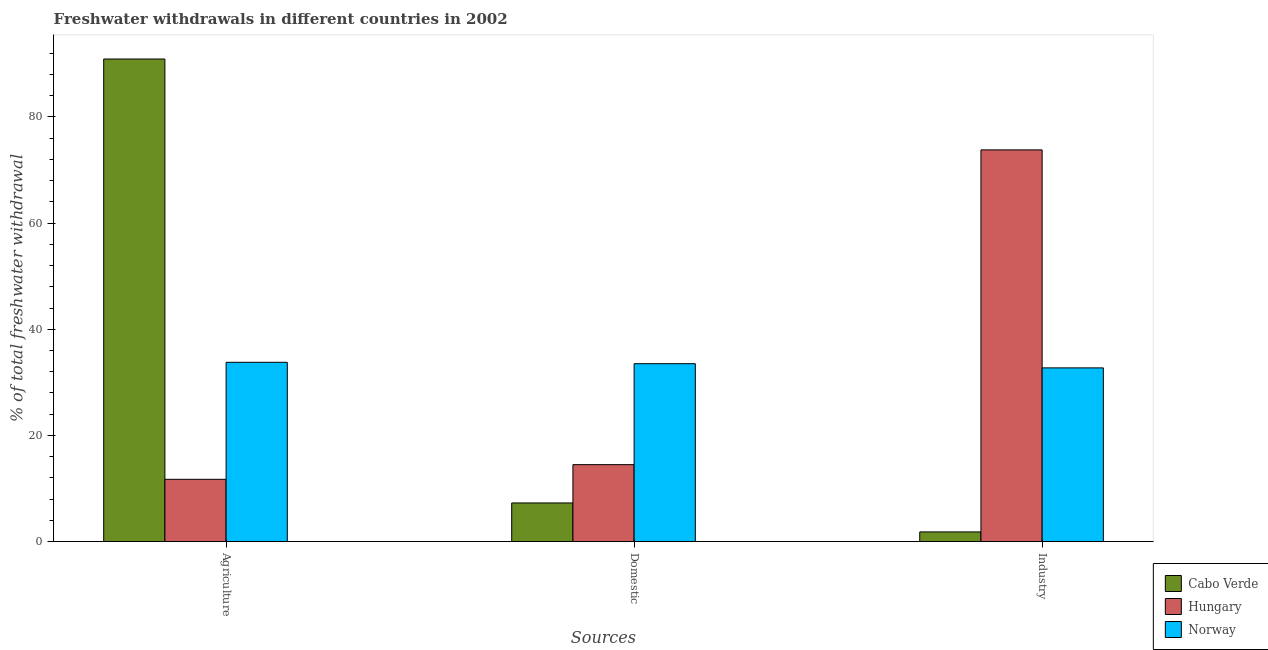How many different coloured bars are there?
Your answer should be compact. 3. Are the number of bars per tick equal to the number of legend labels?
Offer a terse response. Yes. Are the number of bars on each tick of the X-axis equal?
Your answer should be compact. Yes. How many bars are there on the 2nd tick from the right?
Offer a terse response. 3. What is the label of the 1st group of bars from the left?
Your response must be concise. Agriculture. What is the percentage of freshwater withdrawal for domestic purposes in Cabo Verde?
Give a very brief answer. 7.27. Across all countries, what is the maximum percentage of freshwater withdrawal for industry?
Provide a short and direct response. 73.79. Across all countries, what is the minimum percentage of freshwater withdrawal for domestic purposes?
Make the answer very short. 7.27. In which country was the percentage of freshwater withdrawal for domestic purposes maximum?
Offer a terse response. Norway. In which country was the percentage of freshwater withdrawal for domestic purposes minimum?
Provide a short and direct response. Cabo Verde. What is the total percentage of freshwater withdrawal for agriculture in the graph?
Your response must be concise. 136.41. What is the difference between the percentage of freshwater withdrawal for domestic purposes in Cabo Verde and that in Norway?
Your answer should be very brief. -26.24. What is the difference between the percentage of freshwater withdrawal for agriculture in Hungary and the percentage of freshwater withdrawal for domestic purposes in Norway?
Ensure brevity in your answer.  -21.78. What is the average percentage of freshwater withdrawal for industry per country?
Your answer should be very brief. 36.11. What is the difference between the percentage of freshwater withdrawal for domestic purposes and percentage of freshwater withdrawal for industry in Cabo Verde?
Offer a very short reply. 5.46. What is the ratio of the percentage of freshwater withdrawal for agriculture in Hungary to that in Norway?
Ensure brevity in your answer.  0.35. What is the difference between the highest and the second highest percentage of freshwater withdrawal for domestic purposes?
Ensure brevity in your answer.  19.02. What is the difference between the highest and the lowest percentage of freshwater withdrawal for industry?
Provide a short and direct response. 71.97. Is the sum of the percentage of freshwater withdrawal for domestic purposes in Norway and Hungary greater than the maximum percentage of freshwater withdrawal for industry across all countries?
Offer a terse response. No. What does the 3rd bar from the left in Domestic represents?
Provide a succinct answer. Norway. What does the 3rd bar from the right in Agriculture represents?
Offer a very short reply. Cabo Verde. Are all the bars in the graph horizontal?
Give a very brief answer. No. How many countries are there in the graph?
Your response must be concise. 3. Are the values on the major ticks of Y-axis written in scientific E-notation?
Ensure brevity in your answer.  No. Does the graph contain any zero values?
Your response must be concise. No. Where does the legend appear in the graph?
Offer a terse response. Bottom right. How many legend labels are there?
Your answer should be very brief. 3. How are the legend labels stacked?
Give a very brief answer. Vertical. What is the title of the graph?
Ensure brevity in your answer.  Freshwater withdrawals in different countries in 2002. What is the label or title of the X-axis?
Your response must be concise. Sources. What is the label or title of the Y-axis?
Ensure brevity in your answer.  % of total freshwater withdrawal. What is the % of total freshwater withdrawal in Cabo Verde in Agriculture?
Provide a succinct answer. 90.91. What is the % of total freshwater withdrawal in Hungary in Agriculture?
Keep it short and to the point. 11.73. What is the % of total freshwater withdrawal of Norway in Agriculture?
Provide a succinct answer. 33.77. What is the % of total freshwater withdrawal of Cabo Verde in Domestic?
Give a very brief answer. 7.27. What is the % of total freshwater withdrawal of Hungary in Domestic?
Keep it short and to the point. 14.49. What is the % of total freshwater withdrawal in Norway in Domestic?
Offer a very short reply. 33.51. What is the % of total freshwater withdrawal in Cabo Verde in Industry?
Provide a short and direct response. 1.82. What is the % of total freshwater withdrawal in Hungary in Industry?
Keep it short and to the point. 73.79. What is the % of total freshwater withdrawal of Norway in Industry?
Your response must be concise. 32.72. Across all Sources, what is the maximum % of total freshwater withdrawal of Cabo Verde?
Your response must be concise. 90.91. Across all Sources, what is the maximum % of total freshwater withdrawal of Hungary?
Make the answer very short. 73.79. Across all Sources, what is the maximum % of total freshwater withdrawal in Norway?
Make the answer very short. 33.77. Across all Sources, what is the minimum % of total freshwater withdrawal of Cabo Verde?
Offer a very short reply. 1.82. Across all Sources, what is the minimum % of total freshwater withdrawal of Hungary?
Ensure brevity in your answer.  11.73. Across all Sources, what is the minimum % of total freshwater withdrawal in Norway?
Your answer should be compact. 32.72. What is the total % of total freshwater withdrawal in Cabo Verde in the graph?
Your answer should be very brief. 100. What is the total % of total freshwater withdrawal in Hungary in the graph?
Your answer should be compact. 100.01. What is the difference between the % of total freshwater withdrawal of Cabo Verde in Agriculture and that in Domestic?
Provide a succinct answer. 83.64. What is the difference between the % of total freshwater withdrawal in Hungary in Agriculture and that in Domestic?
Ensure brevity in your answer.  -2.76. What is the difference between the % of total freshwater withdrawal in Norway in Agriculture and that in Domestic?
Your answer should be very brief. 0.26. What is the difference between the % of total freshwater withdrawal of Cabo Verde in Agriculture and that in Industry?
Your answer should be very brief. 89.09. What is the difference between the % of total freshwater withdrawal in Hungary in Agriculture and that in Industry?
Offer a very short reply. -62.06. What is the difference between the % of total freshwater withdrawal of Norway in Agriculture and that in Industry?
Offer a very short reply. 1.05. What is the difference between the % of total freshwater withdrawal of Cabo Verde in Domestic and that in Industry?
Give a very brief answer. 5.46. What is the difference between the % of total freshwater withdrawal of Hungary in Domestic and that in Industry?
Your response must be concise. -59.3. What is the difference between the % of total freshwater withdrawal in Norway in Domestic and that in Industry?
Provide a short and direct response. 0.79. What is the difference between the % of total freshwater withdrawal of Cabo Verde in Agriculture and the % of total freshwater withdrawal of Hungary in Domestic?
Offer a very short reply. 76.42. What is the difference between the % of total freshwater withdrawal of Cabo Verde in Agriculture and the % of total freshwater withdrawal of Norway in Domestic?
Your answer should be compact. 57.4. What is the difference between the % of total freshwater withdrawal of Hungary in Agriculture and the % of total freshwater withdrawal of Norway in Domestic?
Keep it short and to the point. -21.78. What is the difference between the % of total freshwater withdrawal in Cabo Verde in Agriculture and the % of total freshwater withdrawal in Hungary in Industry?
Ensure brevity in your answer.  17.12. What is the difference between the % of total freshwater withdrawal of Cabo Verde in Agriculture and the % of total freshwater withdrawal of Norway in Industry?
Ensure brevity in your answer.  58.19. What is the difference between the % of total freshwater withdrawal in Hungary in Agriculture and the % of total freshwater withdrawal in Norway in Industry?
Your answer should be compact. -20.99. What is the difference between the % of total freshwater withdrawal in Cabo Verde in Domestic and the % of total freshwater withdrawal in Hungary in Industry?
Your answer should be compact. -66.52. What is the difference between the % of total freshwater withdrawal in Cabo Verde in Domestic and the % of total freshwater withdrawal in Norway in Industry?
Offer a terse response. -25.45. What is the difference between the % of total freshwater withdrawal of Hungary in Domestic and the % of total freshwater withdrawal of Norway in Industry?
Keep it short and to the point. -18.23. What is the average % of total freshwater withdrawal of Cabo Verde per Sources?
Your answer should be compact. 33.33. What is the average % of total freshwater withdrawal in Hungary per Sources?
Provide a short and direct response. 33.34. What is the average % of total freshwater withdrawal in Norway per Sources?
Make the answer very short. 33.33. What is the difference between the % of total freshwater withdrawal of Cabo Verde and % of total freshwater withdrawal of Hungary in Agriculture?
Make the answer very short. 79.18. What is the difference between the % of total freshwater withdrawal in Cabo Verde and % of total freshwater withdrawal in Norway in Agriculture?
Your response must be concise. 57.14. What is the difference between the % of total freshwater withdrawal of Hungary and % of total freshwater withdrawal of Norway in Agriculture?
Offer a terse response. -22.04. What is the difference between the % of total freshwater withdrawal of Cabo Verde and % of total freshwater withdrawal of Hungary in Domestic?
Provide a short and direct response. -7.22. What is the difference between the % of total freshwater withdrawal of Cabo Verde and % of total freshwater withdrawal of Norway in Domestic?
Your answer should be very brief. -26.24. What is the difference between the % of total freshwater withdrawal in Hungary and % of total freshwater withdrawal in Norway in Domestic?
Ensure brevity in your answer.  -19.02. What is the difference between the % of total freshwater withdrawal in Cabo Verde and % of total freshwater withdrawal in Hungary in Industry?
Provide a succinct answer. -71.97. What is the difference between the % of total freshwater withdrawal in Cabo Verde and % of total freshwater withdrawal in Norway in Industry?
Give a very brief answer. -30.9. What is the difference between the % of total freshwater withdrawal in Hungary and % of total freshwater withdrawal in Norway in Industry?
Offer a very short reply. 41.07. What is the ratio of the % of total freshwater withdrawal of Cabo Verde in Agriculture to that in Domestic?
Ensure brevity in your answer.  12.5. What is the ratio of the % of total freshwater withdrawal of Hungary in Agriculture to that in Domestic?
Offer a terse response. 0.81. What is the ratio of the % of total freshwater withdrawal in Cabo Verde in Agriculture to that in Industry?
Ensure brevity in your answer.  50.01. What is the ratio of the % of total freshwater withdrawal of Hungary in Agriculture to that in Industry?
Keep it short and to the point. 0.16. What is the ratio of the % of total freshwater withdrawal of Norway in Agriculture to that in Industry?
Make the answer very short. 1.03. What is the ratio of the % of total freshwater withdrawal of Cabo Verde in Domestic to that in Industry?
Your answer should be very brief. 4. What is the ratio of the % of total freshwater withdrawal in Hungary in Domestic to that in Industry?
Offer a very short reply. 0.2. What is the ratio of the % of total freshwater withdrawal of Norway in Domestic to that in Industry?
Provide a short and direct response. 1.02. What is the difference between the highest and the second highest % of total freshwater withdrawal in Cabo Verde?
Your answer should be compact. 83.64. What is the difference between the highest and the second highest % of total freshwater withdrawal in Hungary?
Keep it short and to the point. 59.3. What is the difference between the highest and the second highest % of total freshwater withdrawal of Norway?
Offer a very short reply. 0.26. What is the difference between the highest and the lowest % of total freshwater withdrawal of Cabo Verde?
Provide a succinct answer. 89.09. What is the difference between the highest and the lowest % of total freshwater withdrawal of Hungary?
Offer a very short reply. 62.06. What is the difference between the highest and the lowest % of total freshwater withdrawal of Norway?
Provide a short and direct response. 1.05. 